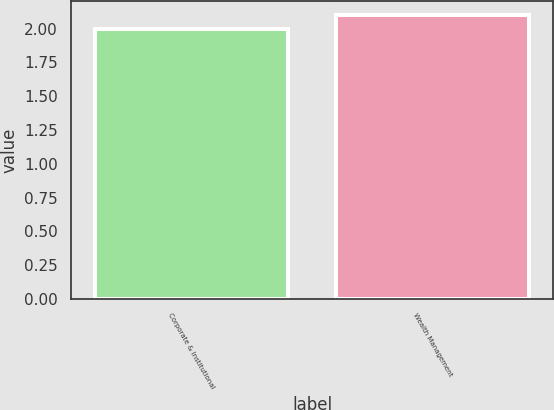Convert chart. <chart><loc_0><loc_0><loc_500><loc_500><bar_chart><fcel>Corporate & Institutional<fcel>Wealth Management<nl><fcel>2<fcel>2.1<nl></chart> 